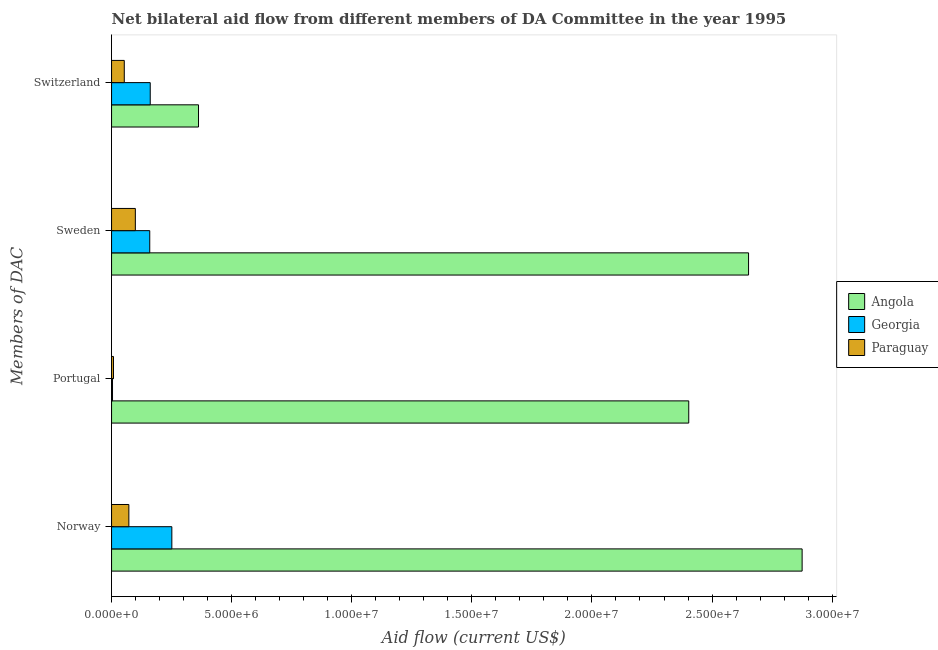How many different coloured bars are there?
Give a very brief answer. 3. Are the number of bars on each tick of the Y-axis equal?
Your response must be concise. Yes. How many bars are there on the 3rd tick from the bottom?
Give a very brief answer. 3. What is the amount of aid given by switzerland in Georgia?
Give a very brief answer. 1.61e+06. Across all countries, what is the maximum amount of aid given by norway?
Give a very brief answer. 2.88e+07. Across all countries, what is the minimum amount of aid given by switzerland?
Offer a very short reply. 5.30e+05. In which country was the amount of aid given by portugal maximum?
Your response must be concise. Angola. In which country was the amount of aid given by switzerland minimum?
Your answer should be very brief. Paraguay. What is the total amount of aid given by switzerland in the graph?
Provide a succinct answer. 5.76e+06. What is the difference between the amount of aid given by norway in Georgia and that in Paraguay?
Keep it short and to the point. 1.79e+06. What is the difference between the amount of aid given by sweden in Georgia and the amount of aid given by switzerland in Angola?
Your answer should be compact. -2.03e+06. What is the average amount of aid given by sweden per country?
Offer a terse response. 9.70e+06. What is the difference between the amount of aid given by switzerland and amount of aid given by portugal in Georgia?
Provide a succinct answer. 1.57e+06. What is the ratio of the amount of aid given by sweden in Paraguay to that in Angola?
Make the answer very short. 0.04. Is the difference between the amount of aid given by portugal in Angola and Paraguay greater than the difference between the amount of aid given by switzerland in Angola and Paraguay?
Your answer should be very brief. Yes. What is the difference between the highest and the second highest amount of aid given by switzerland?
Offer a very short reply. 2.01e+06. What is the difference between the highest and the lowest amount of aid given by norway?
Provide a short and direct response. 2.80e+07. Is the sum of the amount of aid given by switzerland in Angola and Georgia greater than the maximum amount of aid given by sweden across all countries?
Your answer should be compact. No. What does the 3rd bar from the top in Sweden represents?
Offer a very short reply. Angola. What does the 2nd bar from the bottom in Norway represents?
Give a very brief answer. Georgia. Is it the case that in every country, the sum of the amount of aid given by norway and amount of aid given by portugal is greater than the amount of aid given by sweden?
Ensure brevity in your answer.  No. Are all the bars in the graph horizontal?
Ensure brevity in your answer.  Yes. What is the difference between two consecutive major ticks on the X-axis?
Your response must be concise. 5.00e+06. Does the graph contain any zero values?
Your answer should be very brief. No. Where does the legend appear in the graph?
Your response must be concise. Center right. How many legend labels are there?
Give a very brief answer. 3. How are the legend labels stacked?
Offer a terse response. Vertical. What is the title of the graph?
Offer a very short reply. Net bilateral aid flow from different members of DA Committee in the year 1995. What is the label or title of the X-axis?
Offer a very short reply. Aid flow (current US$). What is the label or title of the Y-axis?
Ensure brevity in your answer.  Members of DAC. What is the Aid flow (current US$) of Angola in Norway?
Ensure brevity in your answer.  2.88e+07. What is the Aid flow (current US$) in Georgia in Norway?
Provide a succinct answer. 2.51e+06. What is the Aid flow (current US$) in Paraguay in Norway?
Ensure brevity in your answer.  7.20e+05. What is the Aid flow (current US$) in Angola in Portugal?
Offer a very short reply. 2.40e+07. What is the Aid flow (current US$) of Angola in Sweden?
Keep it short and to the point. 2.65e+07. What is the Aid flow (current US$) in Georgia in Sweden?
Keep it short and to the point. 1.59e+06. What is the Aid flow (current US$) of Paraguay in Sweden?
Ensure brevity in your answer.  9.90e+05. What is the Aid flow (current US$) in Angola in Switzerland?
Provide a short and direct response. 3.62e+06. What is the Aid flow (current US$) in Georgia in Switzerland?
Your answer should be very brief. 1.61e+06. What is the Aid flow (current US$) of Paraguay in Switzerland?
Provide a succinct answer. 5.30e+05. Across all Members of DAC, what is the maximum Aid flow (current US$) of Angola?
Offer a very short reply. 2.88e+07. Across all Members of DAC, what is the maximum Aid flow (current US$) of Georgia?
Your answer should be very brief. 2.51e+06. Across all Members of DAC, what is the maximum Aid flow (current US$) in Paraguay?
Keep it short and to the point. 9.90e+05. Across all Members of DAC, what is the minimum Aid flow (current US$) of Angola?
Make the answer very short. 3.62e+06. Across all Members of DAC, what is the minimum Aid flow (current US$) of Georgia?
Offer a terse response. 4.00e+04. What is the total Aid flow (current US$) in Angola in the graph?
Ensure brevity in your answer.  8.29e+07. What is the total Aid flow (current US$) of Georgia in the graph?
Offer a very short reply. 5.75e+06. What is the total Aid flow (current US$) in Paraguay in the graph?
Offer a very short reply. 2.32e+06. What is the difference between the Aid flow (current US$) of Angola in Norway and that in Portugal?
Keep it short and to the point. 4.72e+06. What is the difference between the Aid flow (current US$) of Georgia in Norway and that in Portugal?
Your answer should be compact. 2.47e+06. What is the difference between the Aid flow (current US$) of Paraguay in Norway and that in Portugal?
Provide a succinct answer. 6.40e+05. What is the difference between the Aid flow (current US$) in Angola in Norway and that in Sweden?
Make the answer very short. 2.23e+06. What is the difference between the Aid flow (current US$) in Georgia in Norway and that in Sweden?
Provide a succinct answer. 9.20e+05. What is the difference between the Aid flow (current US$) of Angola in Norway and that in Switzerland?
Ensure brevity in your answer.  2.51e+07. What is the difference between the Aid flow (current US$) of Paraguay in Norway and that in Switzerland?
Provide a succinct answer. 1.90e+05. What is the difference between the Aid flow (current US$) of Angola in Portugal and that in Sweden?
Your answer should be very brief. -2.49e+06. What is the difference between the Aid flow (current US$) in Georgia in Portugal and that in Sweden?
Ensure brevity in your answer.  -1.55e+06. What is the difference between the Aid flow (current US$) in Paraguay in Portugal and that in Sweden?
Your answer should be compact. -9.10e+05. What is the difference between the Aid flow (current US$) in Angola in Portugal and that in Switzerland?
Offer a terse response. 2.04e+07. What is the difference between the Aid flow (current US$) in Georgia in Portugal and that in Switzerland?
Provide a short and direct response. -1.57e+06. What is the difference between the Aid flow (current US$) in Paraguay in Portugal and that in Switzerland?
Your response must be concise. -4.50e+05. What is the difference between the Aid flow (current US$) of Angola in Sweden and that in Switzerland?
Your answer should be very brief. 2.29e+07. What is the difference between the Aid flow (current US$) in Paraguay in Sweden and that in Switzerland?
Your answer should be very brief. 4.60e+05. What is the difference between the Aid flow (current US$) of Angola in Norway and the Aid flow (current US$) of Georgia in Portugal?
Make the answer very short. 2.87e+07. What is the difference between the Aid flow (current US$) of Angola in Norway and the Aid flow (current US$) of Paraguay in Portugal?
Offer a terse response. 2.87e+07. What is the difference between the Aid flow (current US$) of Georgia in Norway and the Aid flow (current US$) of Paraguay in Portugal?
Offer a terse response. 2.43e+06. What is the difference between the Aid flow (current US$) of Angola in Norway and the Aid flow (current US$) of Georgia in Sweden?
Provide a short and direct response. 2.72e+07. What is the difference between the Aid flow (current US$) of Angola in Norway and the Aid flow (current US$) of Paraguay in Sweden?
Your response must be concise. 2.78e+07. What is the difference between the Aid flow (current US$) in Georgia in Norway and the Aid flow (current US$) in Paraguay in Sweden?
Offer a very short reply. 1.52e+06. What is the difference between the Aid flow (current US$) of Angola in Norway and the Aid flow (current US$) of Georgia in Switzerland?
Offer a very short reply. 2.71e+07. What is the difference between the Aid flow (current US$) in Angola in Norway and the Aid flow (current US$) in Paraguay in Switzerland?
Keep it short and to the point. 2.82e+07. What is the difference between the Aid flow (current US$) of Georgia in Norway and the Aid flow (current US$) of Paraguay in Switzerland?
Your answer should be very brief. 1.98e+06. What is the difference between the Aid flow (current US$) of Angola in Portugal and the Aid flow (current US$) of Georgia in Sweden?
Keep it short and to the point. 2.24e+07. What is the difference between the Aid flow (current US$) of Angola in Portugal and the Aid flow (current US$) of Paraguay in Sweden?
Give a very brief answer. 2.30e+07. What is the difference between the Aid flow (current US$) of Georgia in Portugal and the Aid flow (current US$) of Paraguay in Sweden?
Your answer should be compact. -9.50e+05. What is the difference between the Aid flow (current US$) in Angola in Portugal and the Aid flow (current US$) in Georgia in Switzerland?
Make the answer very short. 2.24e+07. What is the difference between the Aid flow (current US$) of Angola in Portugal and the Aid flow (current US$) of Paraguay in Switzerland?
Your answer should be compact. 2.35e+07. What is the difference between the Aid flow (current US$) in Georgia in Portugal and the Aid flow (current US$) in Paraguay in Switzerland?
Give a very brief answer. -4.90e+05. What is the difference between the Aid flow (current US$) in Angola in Sweden and the Aid flow (current US$) in Georgia in Switzerland?
Provide a succinct answer. 2.49e+07. What is the difference between the Aid flow (current US$) in Angola in Sweden and the Aid flow (current US$) in Paraguay in Switzerland?
Provide a succinct answer. 2.60e+07. What is the difference between the Aid flow (current US$) of Georgia in Sweden and the Aid flow (current US$) of Paraguay in Switzerland?
Make the answer very short. 1.06e+06. What is the average Aid flow (current US$) of Angola per Members of DAC?
Provide a succinct answer. 2.07e+07. What is the average Aid flow (current US$) in Georgia per Members of DAC?
Keep it short and to the point. 1.44e+06. What is the average Aid flow (current US$) of Paraguay per Members of DAC?
Make the answer very short. 5.80e+05. What is the difference between the Aid flow (current US$) of Angola and Aid flow (current US$) of Georgia in Norway?
Provide a short and direct response. 2.62e+07. What is the difference between the Aid flow (current US$) in Angola and Aid flow (current US$) in Paraguay in Norway?
Make the answer very short. 2.80e+07. What is the difference between the Aid flow (current US$) in Georgia and Aid flow (current US$) in Paraguay in Norway?
Give a very brief answer. 1.79e+06. What is the difference between the Aid flow (current US$) in Angola and Aid flow (current US$) in Georgia in Portugal?
Provide a short and direct response. 2.40e+07. What is the difference between the Aid flow (current US$) of Angola and Aid flow (current US$) of Paraguay in Portugal?
Provide a short and direct response. 2.40e+07. What is the difference between the Aid flow (current US$) in Angola and Aid flow (current US$) in Georgia in Sweden?
Provide a short and direct response. 2.49e+07. What is the difference between the Aid flow (current US$) of Angola and Aid flow (current US$) of Paraguay in Sweden?
Offer a very short reply. 2.55e+07. What is the difference between the Aid flow (current US$) of Angola and Aid flow (current US$) of Georgia in Switzerland?
Make the answer very short. 2.01e+06. What is the difference between the Aid flow (current US$) of Angola and Aid flow (current US$) of Paraguay in Switzerland?
Offer a terse response. 3.09e+06. What is the difference between the Aid flow (current US$) in Georgia and Aid flow (current US$) in Paraguay in Switzerland?
Provide a succinct answer. 1.08e+06. What is the ratio of the Aid flow (current US$) of Angola in Norway to that in Portugal?
Make the answer very short. 1.2. What is the ratio of the Aid flow (current US$) in Georgia in Norway to that in Portugal?
Offer a very short reply. 62.75. What is the ratio of the Aid flow (current US$) of Angola in Norway to that in Sweden?
Your answer should be very brief. 1.08. What is the ratio of the Aid flow (current US$) of Georgia in Norway to that in Sweden?
Your response must be concise. 1.58. What is the ratio of the Aid flow (current US$) in Paraguay in Norway to that in Sweden?
Make the answer very short. 0.73. What is the ratio of the Aid flow (current US$) of Angola in Norway to that in Switzerland?
Make the answer very short. 7.94. What is the ratio of the Aid flow (current US$) in Georgia in Norway to that in Switzerland?
Give a very brief answer. 1.56. What is the ratio of the Aid flow (current US$) of Paraguay in Norway to that in Switzerland?
Offer a terse response. 1.36. What is the ratio of the Aid flow (current US$) in Angola in Portugal to that in Sweden?
Make the answer very short. 0.91. What is the ratio of the Aid flow (current US$) in Georgia in Portugal to that in Sweden?
Provide a short and direct response. 0.03. What is the ratio of the Aid flow (current US$) of Paraguay in Portugal to that in Sweden?
Your answer should be compact. 0.08. What is the ratio of the Aid flow (current US$) in Angola in Portugal to that in Switzerland?
Your response must be concise. 6.64. What is the ratio of the Aid flow (current US$) of Georgia in Portugal to that in Switzerland?
Give a very brief answer. 0.02. What is the ratio of the Aid flow (current US$) in Paraguay in Portugal to that in Switzerland?
Make the answer very short. 0.15. What is the ratio of the Aid flow (current US$) of Angola in Sweden to that in Switzerland?
Ensure brevity in your answer.  7.33. What is the ratio of the Aid flow (current US$) in Georgia in Sweden to that in Switzerland?
Provide a succinct answer. 0.99. What is the ratio of the Aid flow (current US$) of Paraguay in Sweden to that in Switzerland?
Give a very brief answer. 1.87. What is the difference between the highest and the second highest Aid flow (current US$) in Angola?
Offer a very short reply. 2.23e+06. What is the difference between the highest and the second highest Aid flow (current US$) of Georgia?
Your answer should be compact. 9.00e+05. What is the difference between the highest and the lowest Aid flow (current US$) of Angola?
Make the answer very short. 2.51e+07. What is the difference between the highest and the lowest Aid flow (current US$) of Georgia?
Ensure brevity in your answer.  2.47e+06. What is the difference between the highest and the lowest Aid flow (current US$) of Paraguay?
Offer a very short reply. 9.10e+05. 